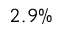Convert formula to latex. <formula><loc_0><loc_0><loc_500><loc_500>2 . 9 \%</formula> 